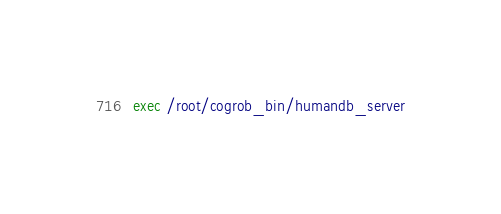<code> <loc_0><loc_0><loc_500><loc_500><_Bash_>exec /root/cogrob_bin/humandb_server
</code> 